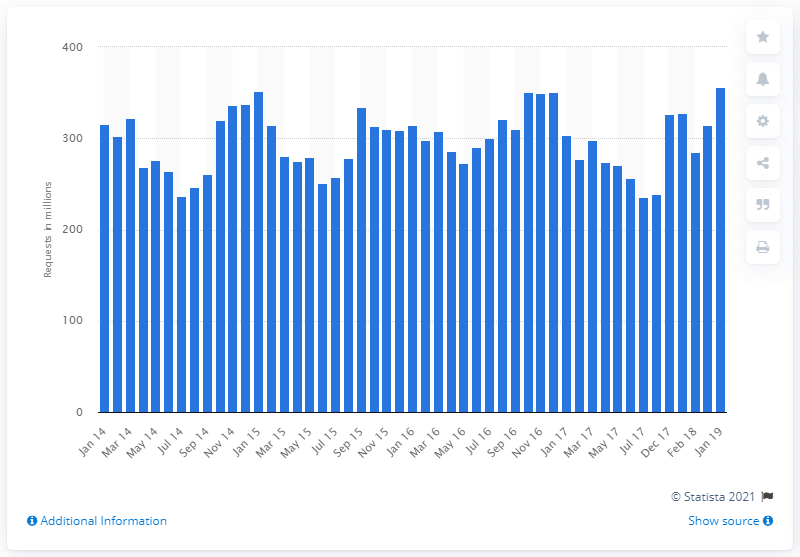Draw attention to some important aspects in this diagram. In January 2019, a total of 356 requests were made. 